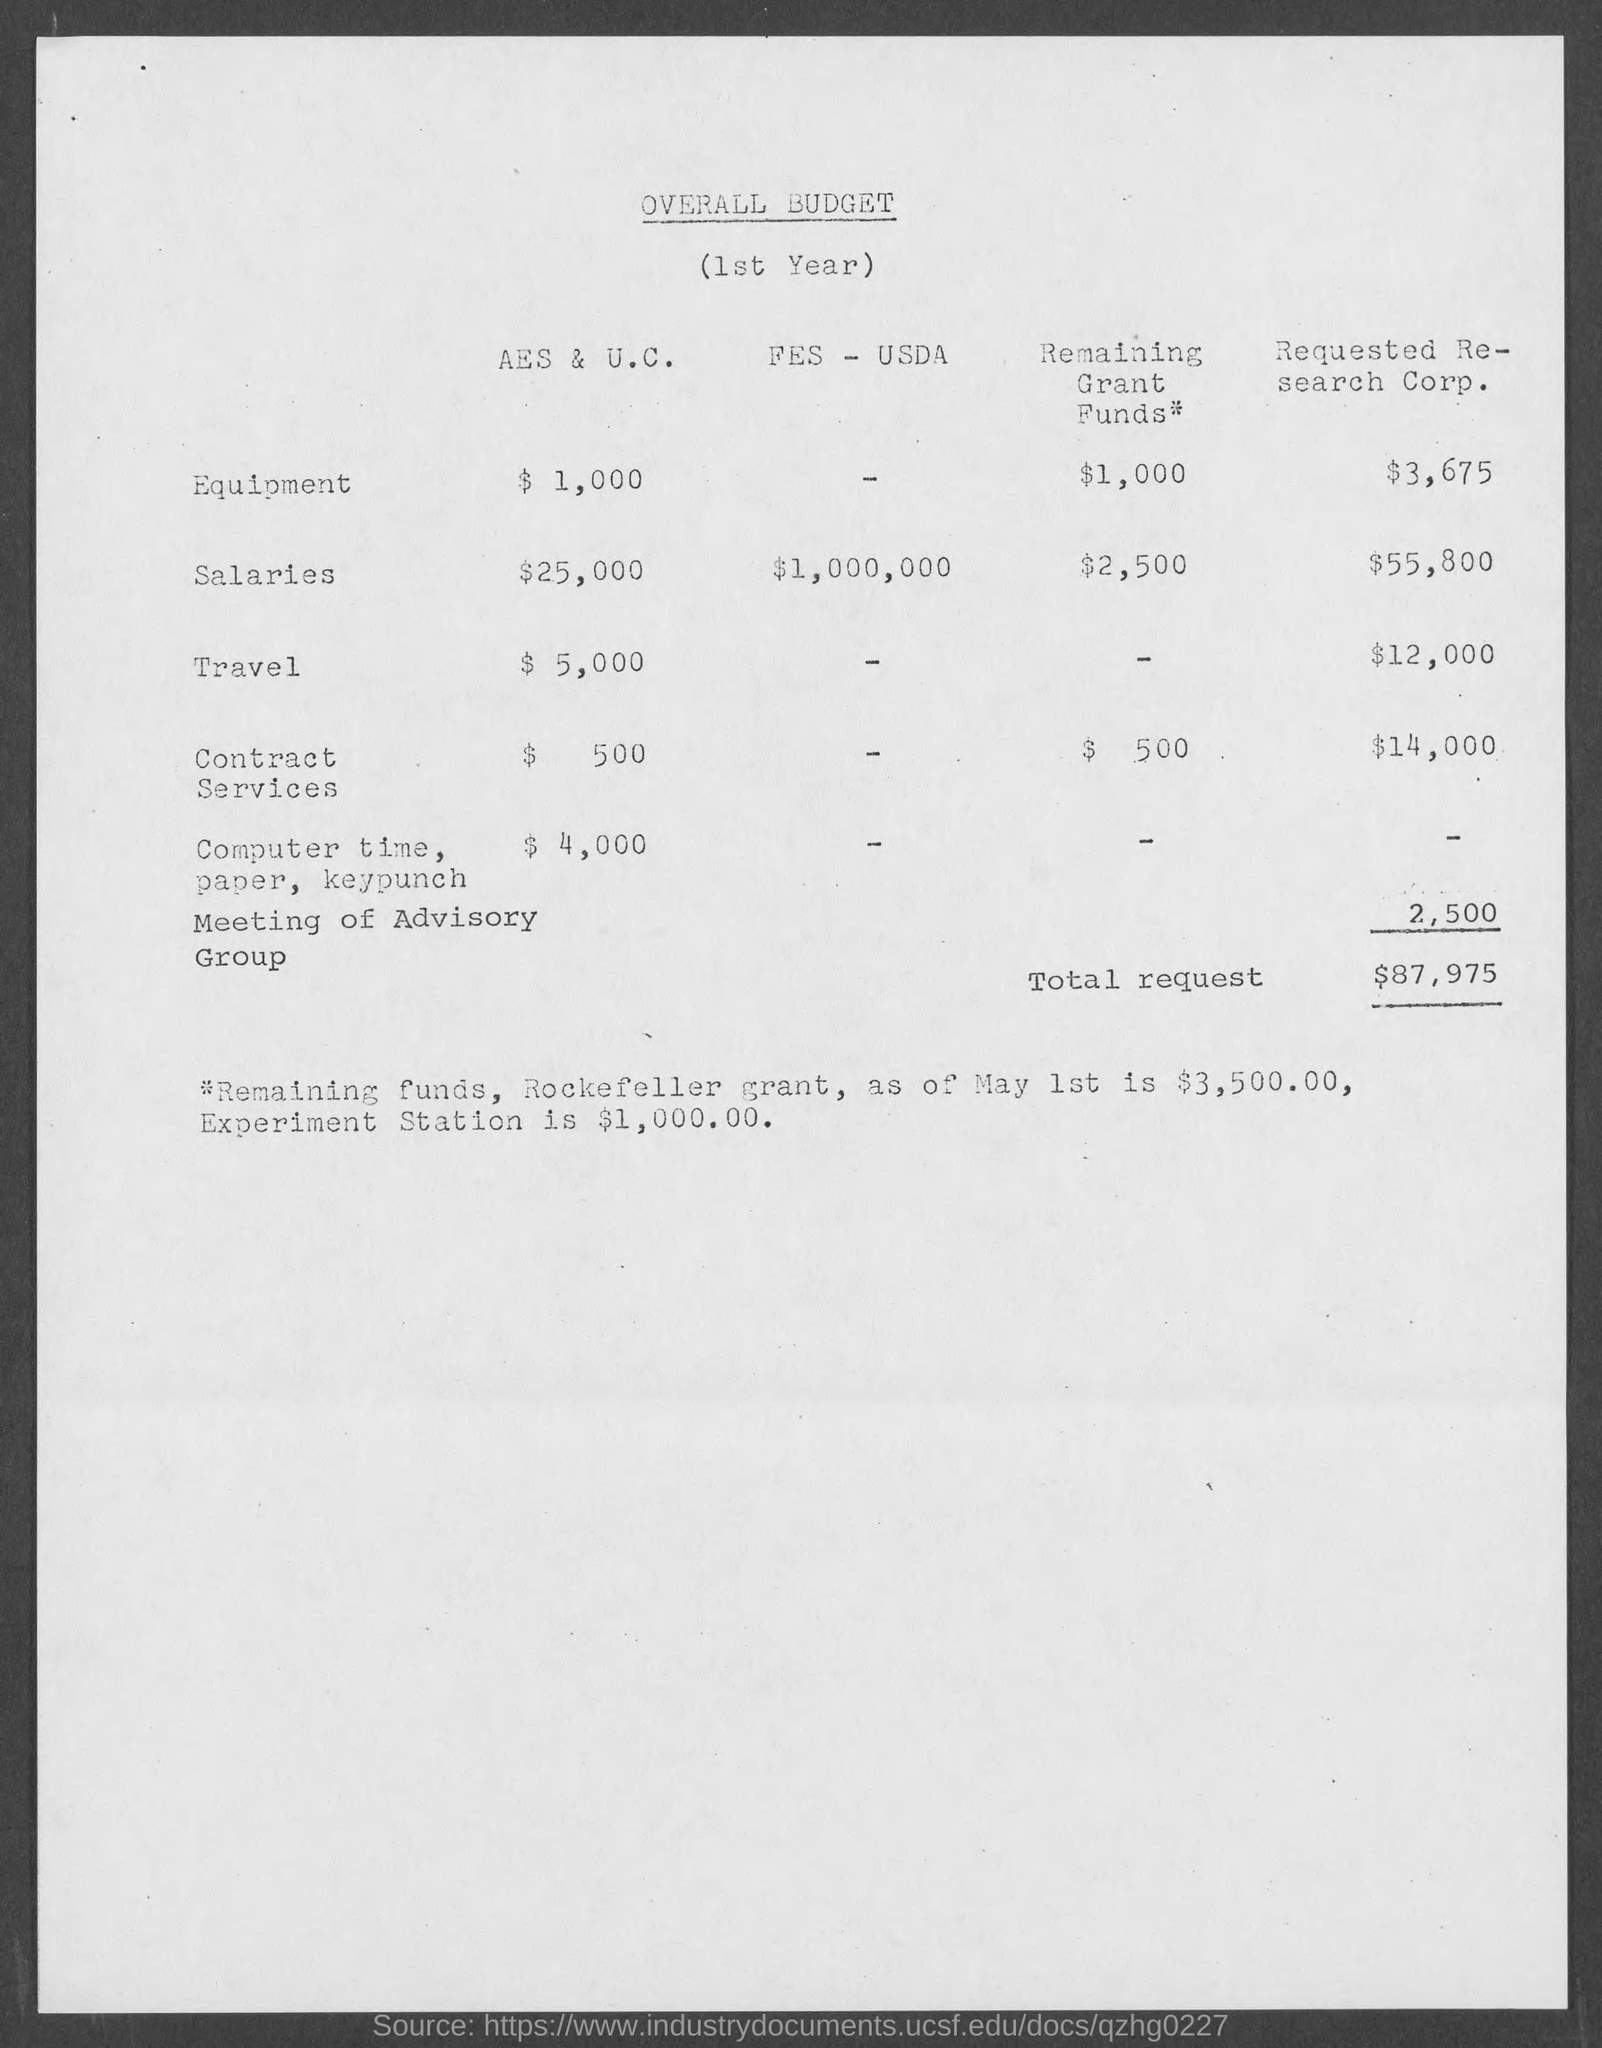What is the Title of the document?
Your answer should be compact. Overall Budget. What is the Cost of Equipment for AES &U.C.?
Offer a terse response. $1,000. What is the Salaries for AES &U.C.?
Your answer should be very brief. $25,000. What is the Cost of Travel for AES &U.C.?
Give a very brief answer. $5,000. What is the Cost of Contract Services for AES &U.C.?
Your response must be concise. $500. What is the Cost of Computer Time, Pper, keypunch for AES &U.C.?
Offer a terse response. $4,000. What is the Total Request?
Provide a succinct answer. $87,975. What is the Cost of Equipment for Requested Research Corp.?
Keep it short and to the point. $3,675. What is the Cost of Travel for Requested Research Corp.?
Ensure brevity in your answer.  $12,000. What is the Cost of Contract Services for Requested Research Corp.?
Keep it short and to the point. $14,000. 